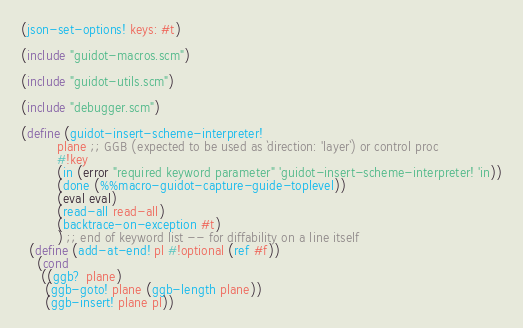Convert code to text. <code><loc_0><loc_0><loc_500><loc_500><_Scheme_>(json-set-options! keys: #t)

(include "guidot-macros.scm")

(include "guidot-utils.scm")

(include "debugger.scm")

(define (guidot-insert-scheme-interpreter!
         plane ;; GGB (expected to be used as `direction: 'layer`) or control proc
         #!key
         (in (error "required keyword parameter" 'guidot-insert-scheme-interpreter! 'in))
         (done (%%macro-guidot-capture-guide-toplevel))
         (eval eval)
         (read-all read-all)
         (backtrace-on-exception #t)
         ) ;; end of keyword list -- for diffability on a line itself
  (define (add-at-end! pl #!optional (ref #f))
    (cond
     ((ggb? plane)
      (ggb-goto! plane (ggb-length plane))
      (ggb-insert! plane pl))</code> 